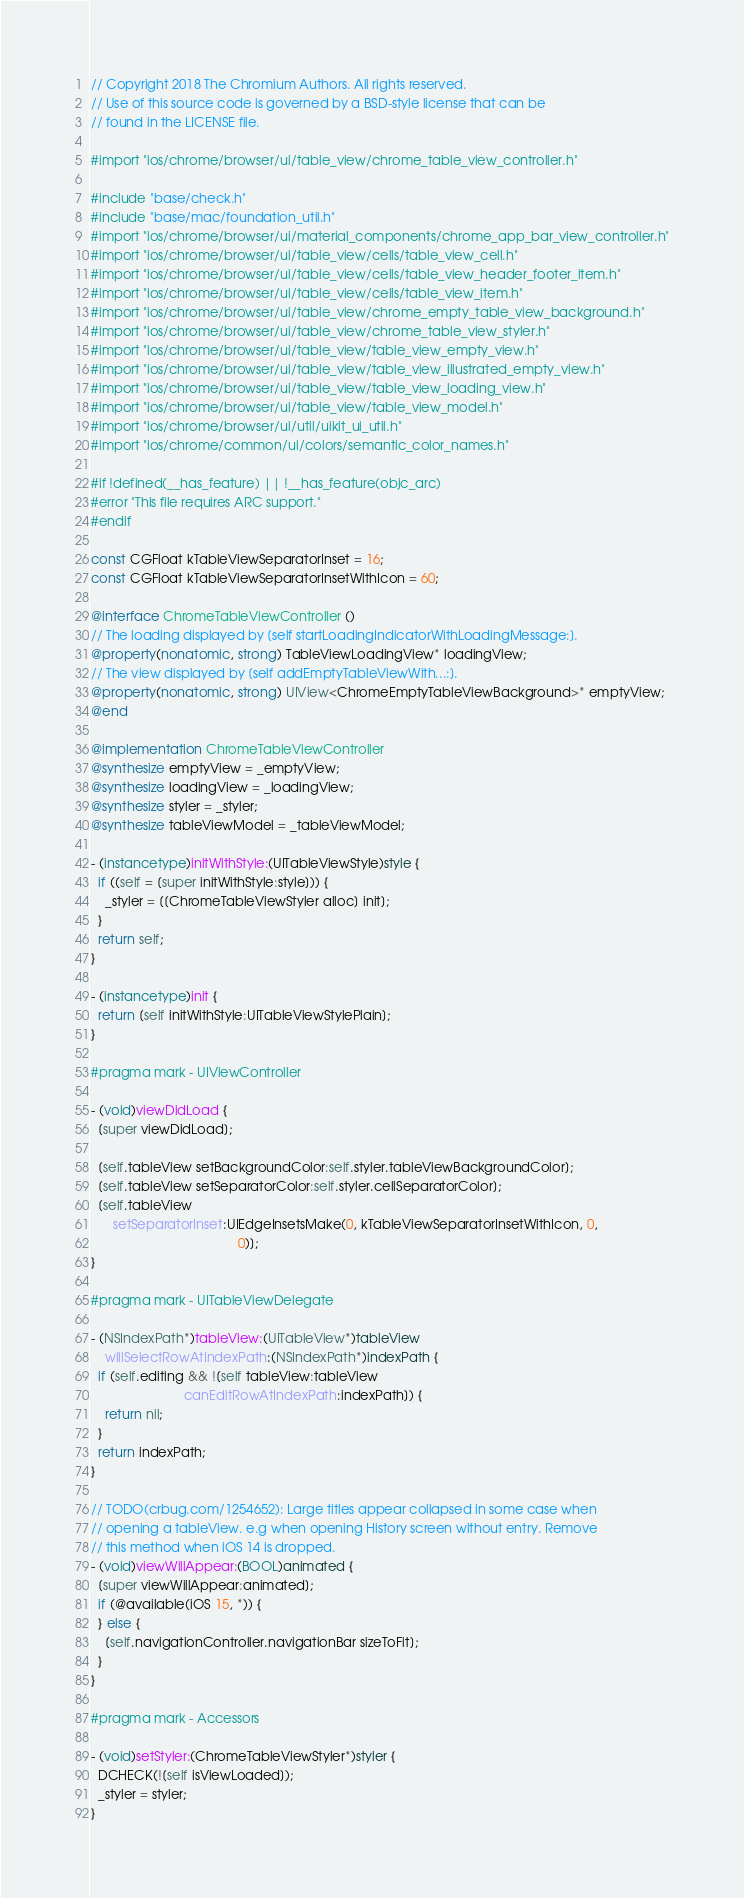<code> <loc_0><loc_0><loc_500><loc_500><_ObjectiveC_>// Copyright 2018 The Chromium Authors. All rights reserved.
// Use of this source code is governed by a BSD-style license that can be
// found in the LICENSE file.

#import "ios/chrome/browser/ui/table_view/chrome_table_view_controller.h"

#include "base/check.h"
#include "base/mac/foundation_util.h"
#import "ios/chrome/browser/ui/material_components/chrome_app_bar_view_controller.h"
#import "ios/chrome/browser/ui/table_view/cells/table_view_cell.h"
#import "ios/chrome/browser/ui/table_view/cells/table_view_header_footer_item.h"
#import "ios/chrome/browser/ui/table_view/cells/table_view_item.h"
#import "ios/chrome/browser/ui/table_view/chrome_empty_table_view_background.h"
#import "ios/chrome/browser/ui/table_view/chrome_table_view_styler.h"
#import "ios/chrome/browser/ui/table_view/table_view_empty_view.h"
#import "ios/chrome/browser/ui/table_view/table_view_illustrated_empty_view.h"
#import "ios/chrome/browser/ui/table_view/table_view_loading_view.h"
#import "ios/chrome/browser/ui/table_view/table_view_model.h"
#import "ios/chrome/browser/ui/util/uikit_ui_util.h"
#import "ios/chrome/common/ui/colors/semantic_color_names.h"

#if !defined(__has_feature) || !__has_feature(objc_arc)
#error "This file requires ARC support."
#endif

const CGFloat kTableViewSeparatorInset = 16;
const CGFloat kTableViewSeparatorInsetWithIcon = 60;

@interface ChromeTableViewController ()
// The loading displayed by [self startLoadingIndicatorWithLoadingMessage:].
@property(nonatomic, strong) TableViewLoadingView* loadingView;
// The view displayed by [self addEmptyTableViewWith...:].
@property(nonatomic, strong) UIView<ChromeEmptyTableViewBackground>* emptyView;
@end

@implementation ChromeTableViewController
@synthesize emptyView = _emptyView;
@synthesize loadingView = _loadingView;
@synthesize styler = _styler;
@synthesize tableViewModel = _tableViewModel;

- (instancetype)initWithStyle:(UITableViewStyle)style {
  if ((self = [super initWithStyle:style])) {
    _styler = [[ChromeTableViewStyler alloc] init];
  }
  return self;
}

- (instancetype)init {
  return [self initWithStyle:UITableViewStylePlain];
}

#pragma mark - UIViewController

- (void)viewDidLoad {
  [super viewDidLoad];

  [self.tableView setBackgroundColor:self.styler.tableViewBackgroundColor];
  [self.tableView setSeparatorColor:self.styler.cellSeparatorColor];
  [self.tableView
      setSeparatorInset:UIEdgeInsetsMake(0, kTableViewSeparatorInsetWithIcon, 0,
                                         0)];
}

#pragma mark - UITableViewDelegate

- (NSIndexPath*)tableView:(UITableView*)tableView
    willSelectRowAtIndexPath:(NSIndexPath*)indexPath {
  if (self.editing && ![self tableView:tableView
                          canEditRowAtIndexPath:indexPath]) {
    return nil;
  }
  return indexPath;
}

// TODO(crbug.com/1254652): Large titles appear collapsed in some case when
// opening a tableView. e.g when opening History screen without entry. Remove
// this method when iOS 14 is dropped.
- (void)viewWillAppear:(BOOL)animated {
  [super viewWillAppear:animated];
  if (@available(iOS 15, *)) {
  } else {
    [self.navigationController.navigationBar sizeToFit];
  }
}

#pragma mark - Accessors

- (void)setStyler:(ChromeTableViewStyler*)styler {
  DCHECK(![self isViewLoaded]);
  _styler = styler;
}
</code> 